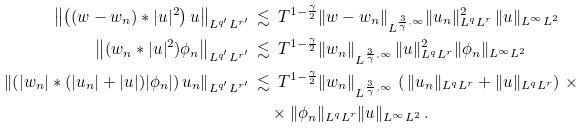Convert formula to latex. <formula><loc_0><loc_0><loc_500><loc_500>\left \| \left ( ( w - w _ { n } ) * | u | ^ { 2 } \right ) u \right \| _ { L ^ { q ^ { \prime } } L ^ { r ^ { \prime } } } \, & \lesssim \, T ^ { 1 - \frac { \gamma } { 2 } } \| w - w _ { n } \| _ { L ^ { \frac { 3 } { \gamma } , \infty } } \| u _ { n } \| ^ { 2 } _ { L ^ { q } L ^ { r } } \, \| u \| _ { L ^ { \infty } L ^ { 2 } } \\ \left \| ( w _ { n } * | u | ^ { 2 } ) \phi _ { n } \right \| _ { L ^ { q ^ { \prime } } L ^ { r ^ { \prime } } } \, & \lesssim \, T ^ { 1 - \frac { \gamma } { 2 } } \| w _ { n } \| _ { L ^ { \frac { 3 } { \gamma } , \infty } } \, \| u \| ^ { 2 } _ { L ^ { q } L ^ { r } } \| \phi _ { n } \| _ { L ^ { \infty } L ^ { 2 } } \\ \left \| \left ( | w _ { n } | * ( | u _ { n } | + | u | ) | \phi _ { n } | \right ) u _ { n } \right \| _ { L ^ { q ^ { \prime } } L ^ { r ^ { \prime } } } \, & \lesssim \, T ^ { 1 - \frac { \gamma } { 2 } } \| w _ { n } \| _ { L ^ { \frac { 3 } { \gamma } , \infty } } \, \left ( \, \| u _ { n } \| _ { L ^ { q } L ^ { r } } + \| u \| _ { L ^ { q } L ^ { r } } \right ) \, \times \\ & \quad \times \| \phi _ { n } \| _ { L ^ { q } L ^ { r } } \| u \| _ { L ^ { \infty } L ^ { 2 } } \, .</formula> 